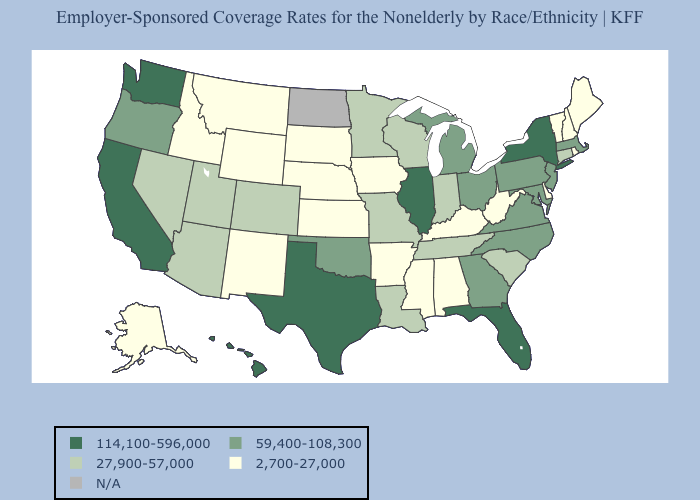What is the value of Wisconsin?
Give a very brief answer. 27,900-57,000. What is the lowest value in states that border Texas?
Give a very brief answer. 2,700-27,000. What is the value of Rhode Island?
Quick response, please. 2,700-27,000. Does Delaware have the lowest value in the South?
Keep it brief. Yes. What is the value of Pennsylvania?
Give a very brief answer. 59,400-108,300. Which states have the lowest value in the Northeast?
Concise answer only. Maine, New Hampshire, Rhode Island, Vermont. How many symbols are there in the legend?
Concise answer only. 5. What is the value of Rhode Island?
Keep it brief. 2,700-27,000. Among the states that border Kentucky , which have the highest value?
Keep it brief. Illinois. What is the highest value in states that border New York?
Short answer required. 59,400-108,300. Name the states that have a value in the range 2,700-27,000?
Quick response, please. Alabama, Alaska, Arkansas, Delaware, Idaho, Iowa, Kansas, Kentucky, Maine, Mississippi, Montana, Nebraska, New Hampshire, New Mexico, Rhode Island, South Dakota, Vermont, West Virginia, Wyoming. What is the highest value in the South ?
Short answer required. 114,100-596,000. Name the states that have a value in the range 59,400-108,300?
Write a very short answer. Georgia, Maryland, Massachusetts, Michigan, New Jersey, North Carolina, Ohio, Oklahoma, Oregon, Pennsylvania, Virginia. Name the states that have a value in the range 2,700-27,000?
Quick response, please. Alabama, Alaska, Arkansas, Delaware, Idaho, Iowa, Kansas, Kentucky, Maine, Mississippi, Montana, Nebraska, New Hampshire, New Mexico, Rhode Island, South Dakota, Vermont, West Virginia, Wyoming. Which states have the highest value in the USA?
Write a very short answer. California, Florida, Hawaii, Illinois, New York, Texas, Washington. 